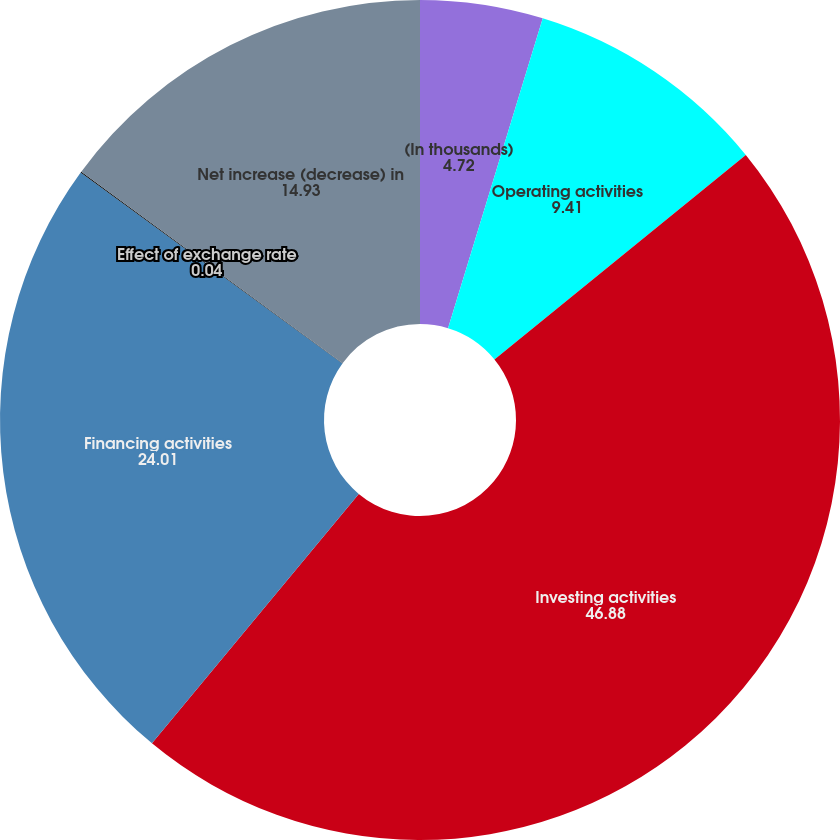<chart> <loc_0><loc_0><loc_500><loc_500><pie_chart><fcel>(In thousands)<fcel>Operating activities<fcel>Investing activities<fcel>Financing activities<fcel>Effect of exchange rate<fcel>Net increase (decrease) in<nl><fcel>4.72%<fcel>9.41%<fcel>46.88%<fcel>24.01%<fcel>0.04%<fcel>14.93%<nl></chart> 